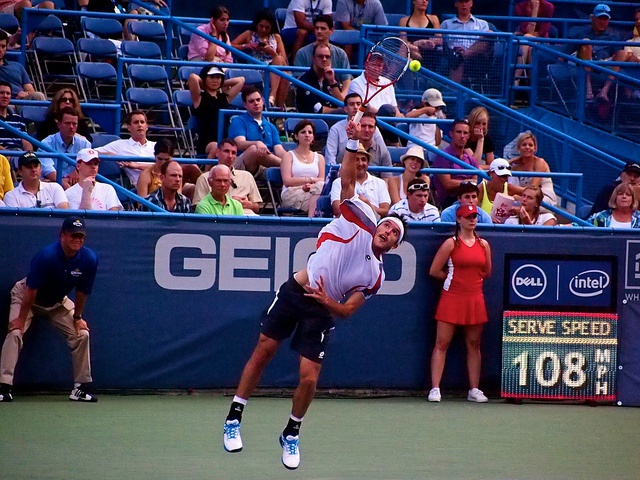Describe the objects in this image and their specific colors. I can see people in brown, black, maroon, violet, and lavender tones, people in brown, black, and maroon tones, people in brown, maroon, and black tones, people in brown, maroon, black, and pink tones, and people in brown, black, maroon, and navy tones in this image. 